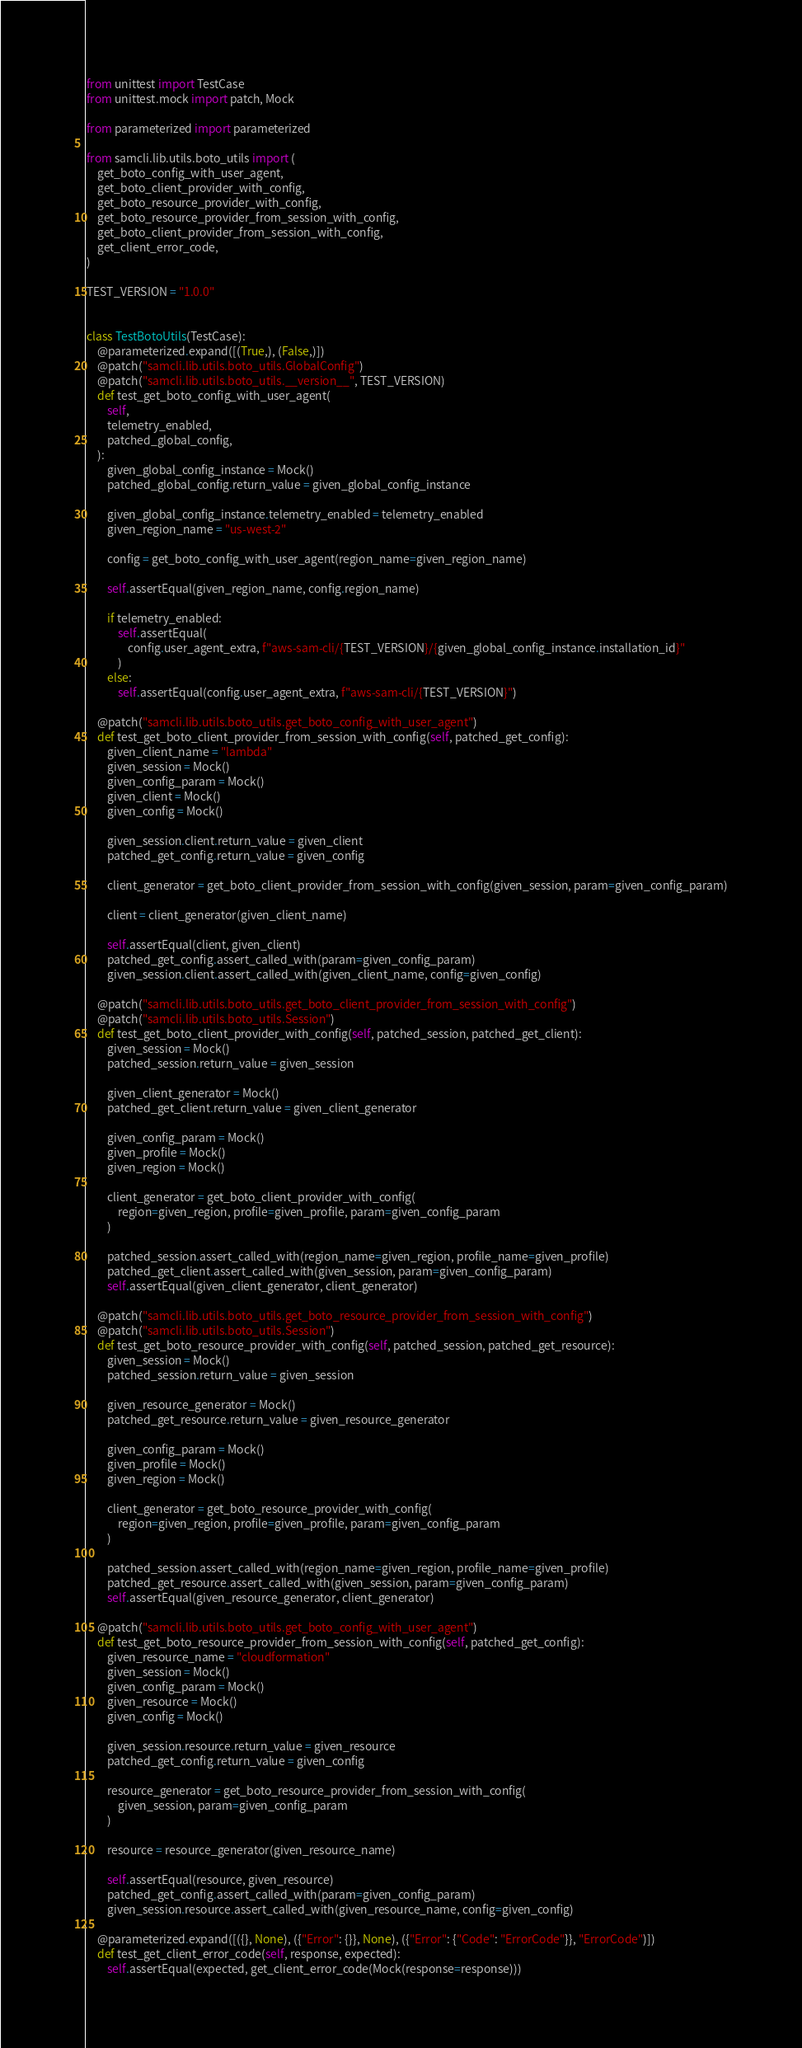Convert code to text. <code><loc_0><loc_0><loc_500><loc_500><_Python_>from unittest import TestCase
from unittest.mock import patch, Mock

from parameterized import parameterized

from samcli.lib.utils.boto_utils import (
    get_boto_config_with_user_agent,
    get_boto_client_provider_with_config,
    get_boto_resource_provider_with_config,
    get_boto_resource_provider_from_session_with_config,
    get_boto_client_provider_from_session_with_config,
    get_client_error_code,
)

TEST_VERSION = "1.0.0"


class TestBotoUtils(TestCase):
    @parameterized.expand([(True,), (False,)])
    @patch("samcli.lib.utils.boto_utils.GlobalConfig")
    @patch("samcli.lib.utils.boto_utils.__version__", TEST_VERSION)
    def test_get_boto_config_with_user_agent(
        self,
        telemetry_enabled,
        patched_global_config,
    ):
        given_global_config_instance = Mock()
        patched_global_config.return_value = given_global_config_instance

        given_global_config_instance.telemetry_enabled = telemetry_enabled
        given_region_name = "us-west-2"

        config = get_boto_config_with_user_agent(region_name=given_region_name)

        self.assertEqual(given_region_name, config.region_name)

        if telemetry_enabled:
            self.assertEqual(
                config.user_agent_extra, f"aws-sam-cli/{TEST_VERSION}/{given_global_config_instance.installation_id}"
            )
        else:
            self.assertEqual(config.user_agent_extra, f"aws-sam-cli/{TEST_VERSION}")

    @patch("samcli.lib.utils.boto_utils.get_boto_config_with_user_agent")
    def test_get_boto_client_provider_from_session_with_config(self, patched_get_config):
        given_client_name = "lambda"
        given_session = Mock()
        given_config_param = Mock()
        given_client = Mock()
        given_config = Mock()

        given_session.client.return_value = given_client
        patched_get_config.return_value = given_config

        client_generator = get_boto_client_provider_from_session_with_config(given_session, param=given_config_param)

        client = client_generator(given_client_name)

        self.assertEqual(client, given_client)
        patched_get_config.assert_called_with(param=given_config_param)
        given_session.client.assert_called_with(given_client_name, config=given_config)

    @patch("samcli.lib.utils.boto_utils.get_boto_client_provider_from_session_with_config")
    @patch("samcli.lib.utils.boto_utils.Session")
    def test_get_boto_client_provider_with_config(self, patched_session, patched_get_client):
        given_session = Mock()
        patched_session.return_value = given_session

        given_client_generator = Mock()
        patched_get_client.return_value = given_client_generator

        given_config_param = Mock()
        given_profile = Mock()
        given_region = Mock()

        client_generator = get_boto_client_provider_with_config(
            region=given_region, profile=given_profile, param=given_config_param
        )

        patched_session.assert_called_with(region_name=given_region, profile_name=given_profile)
        patched_get_client.assert_called_with(given_session, param=given_config_param)
        self.assertEqual(given_client_generator, client_generator)

    @patch("samcli.lib.utils.boto_utils.get_boto_resource_provider_from_session_with_config")
    @patch("samcli.lib.utils.boto_utils.Session")
    def test_get_boto_resource_provider_with_config(self, patched_session, patched_get_resource):
        given_session = Mock()
        patched_session.return_value = given_session

        given_resource_generator = Mock()
        patched_get_resource.return_value = given_resource_generator

        given_config_param = Mock()
        given_profile = Mock()
        given_region = Mock()

        client_generator = get_boto_resource_provider_with_config(
            region=given_region, profile=given_profile, param=given_config_param
        )

        patched_session.assert_called_with(region_name=given_region, profile_name=given_profile)
        patched_get_resource.assert_called_with(given_session, param=given_config_param)
        self.assertEqual(given_resource_generator, client_generator)

    @patch("samcli.lib.utils.boto_utils.get_boto_config_with_user_agent")
    def test_get_boto_resource_provider_from_session_with_config(self, patched_get_config):
        given_resource_name = "cloudformation"
        given_session = Mock()
        given_config_param = Mock()
        given_resource = Mock()
        given_config = Mock()

        given_session.resource.return_value = given_resource
        patched_get_config.return_value = given_config

        resource_generator = get_boto_resource_provider_from_session_with_config(
            given_session, param=given_config_param
        )

        resource = resource_generator(given_resource_name)

        self.assertEqual(resource, given_resource)
        patched_get_config.assert_called_with(param=given_config_param)
        given_session.resource.assert_called_with(given_resource_name, config=given_config)

    @parameterized.expand([({}, None), ({"Error": {}}, None), ({"Error": {"Code": "ErrorCode"}}, "ErrorCode")])
    def test_get_client_error_code(self, response, expected):
        self.assertEqual(expected, get_client_error_code(Mock(response=response)))
</code> 